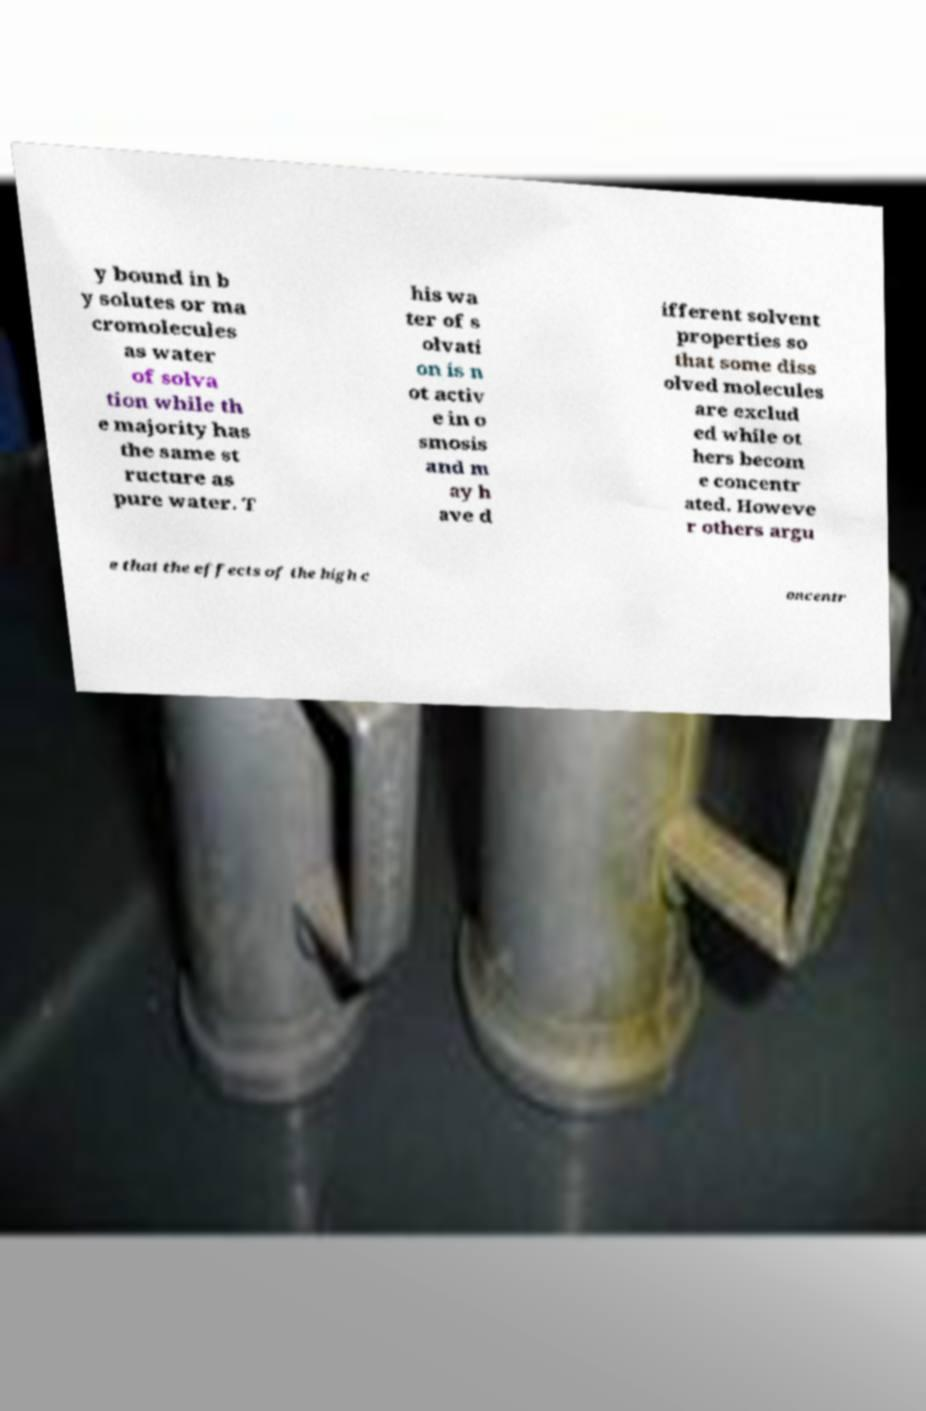Please read and relay the text visible in this image. What does it say? y bound in b y solutes or ma cromolecules as water of solva tion while th e majority has the same st ructure as pure water. T his wa ter of s olvati on is n ot activ e in o smosis and m ay h ave d ifferent solvent properties so that some diss olved molecules are exclud ed while ot hers becom e concentr ated. Howeve r others argu e that the effects of the high c oncentr 